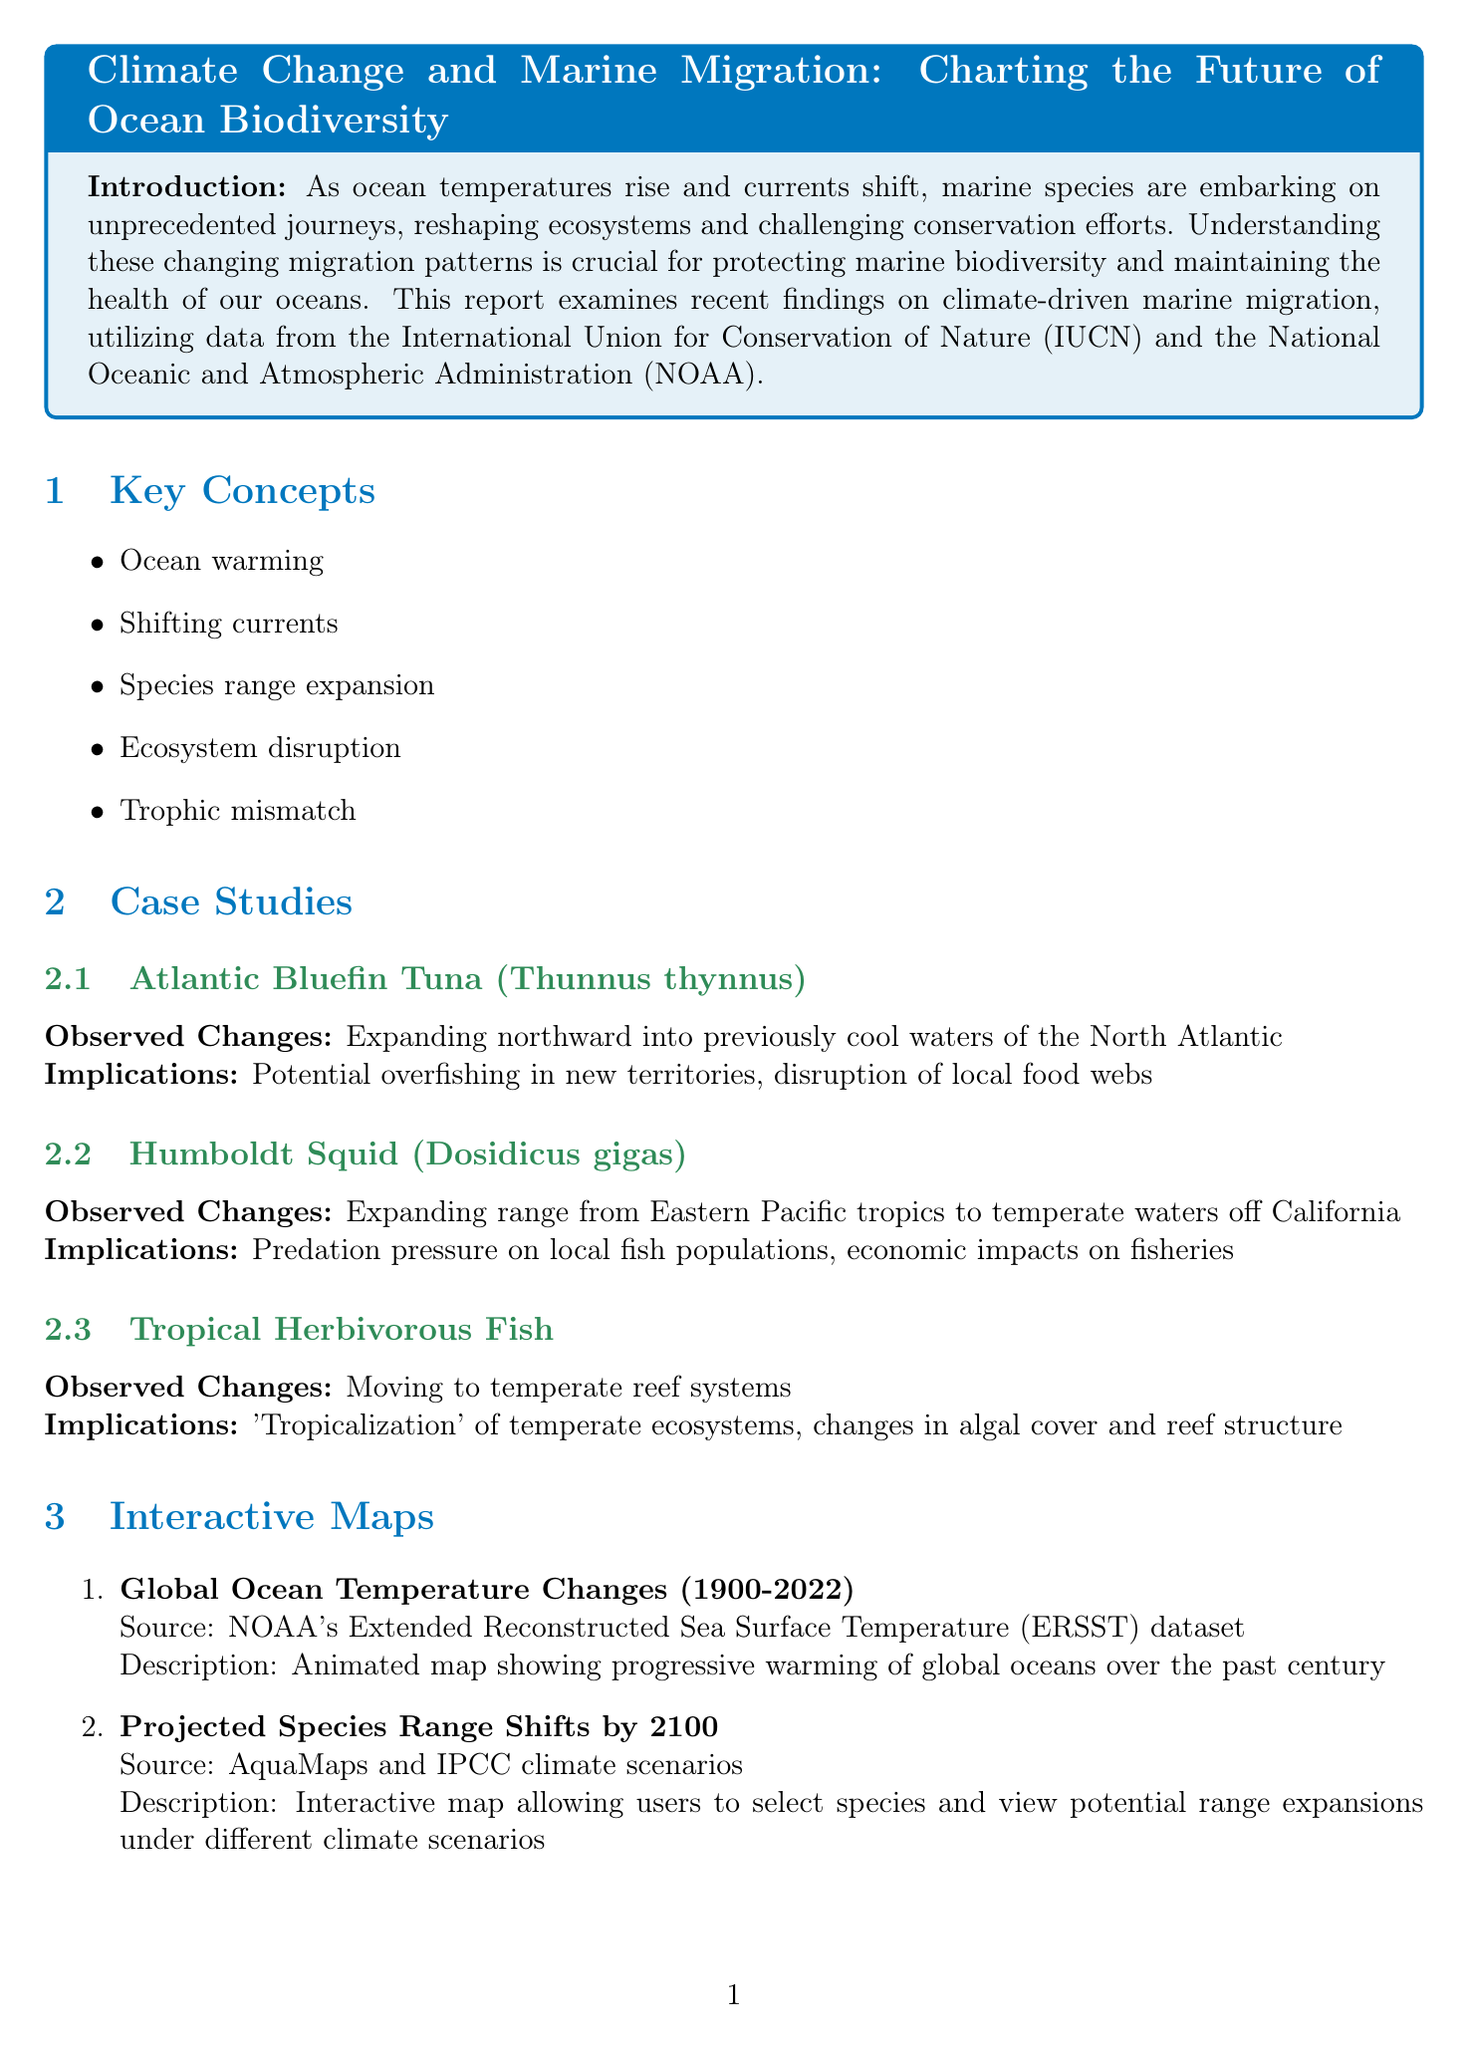What is the title of the report? The title of the report is given at the beginning of the document.
Answer: Climate Change and Marine Migration: Charting the Future of Ocean Biodiversity Which species is observed expanding northward into the North Atlantic? This information is found in the case studies section, detailing specific species changes.
Answer: Atlantic Bluefin Tuna What percentage of species may shift their ranges by 2100 under the Business as Usual scenario? This percentage is mentioned in the future scenarios section under Business as Usual.
Answer: Up to 60% What is the significance of the "Voices from the Changing Seas" element? This element is identified in the storytelling section, showcasing insights from various ocean stakeholders.
Answer: Interview snippets from marine biologists, fishermen, and coastal community members What source is used for the interactive map showing global ocean temperature changes? The source for this interactive map is specified under the interactive maps section.
Answer: NOAA's Extended Reconstructed Sea Surface Temperature (ERSST) dataset How many case studies are included in the document? The number of case studies can be counted in the case studies section of the document.
Answer: Three What does the moderate mitigation scenario project? The projections for this scenario are detailed in the future scenarios section.
Answer: 30-40% of studied marine species may shift or expand their ranges by 2100 What is the primary call to action in the conclusion? The conclusion provides a call to action emphasizing a need for certain strategies.
Answer: Urgent need for continued research, adaptive management strategies, and global action on climate change to protect marine biodiversity 